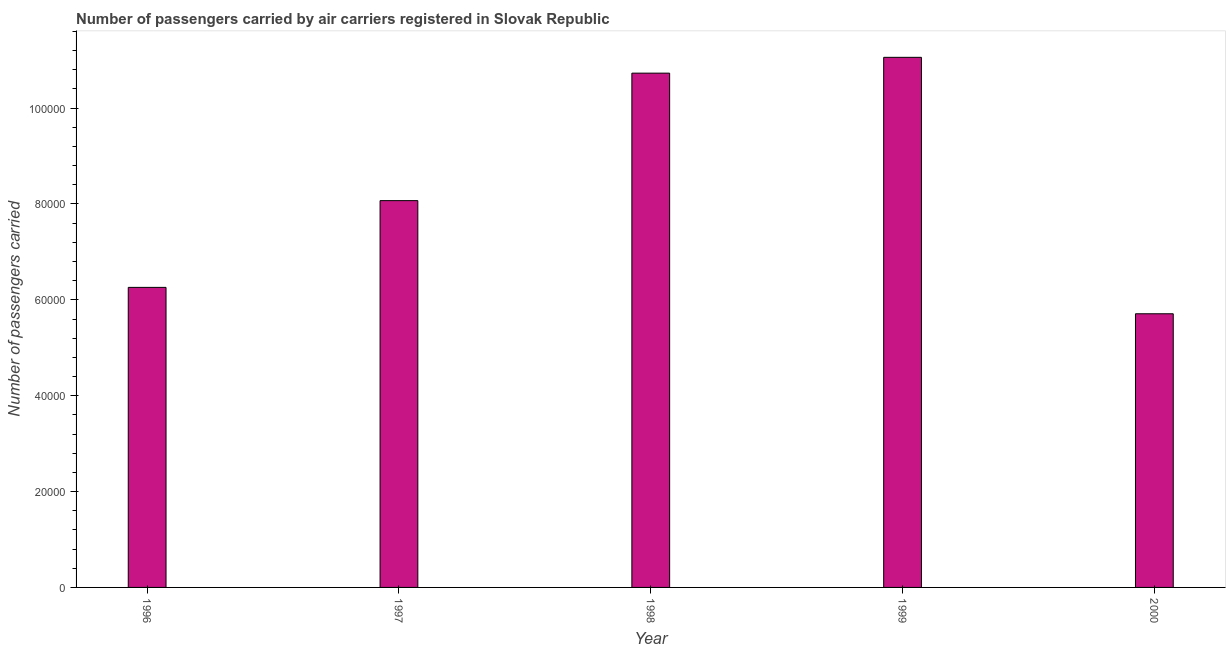Does the graph contain grids?
Your response must be concise. No. What is the title of the graph?
Offer a very short reply. Number of passengers carried by air carriers registered in Slovak Republic. What is the label or title of the Y-axis?
Provide a succinct answer. Number of passengers carried. What is the number of passengers carried in 1996?
Provide a succinct answer. 6.26e+04. Across all years, what is the maximum number of passengers carried?
Ensure brevity in your answer.  1.11e+05. Across all years, what is the minimum number of passengers carried?
Provide a short and direct response. 5.71e+04. In which year was the number of passengers carried minimum?
Ensure brevity in your answer.  2000. What is the sum of the number of passengers carried?
Provide a succinct answer. 4.18e+05. What is the difference between the number of passengers carried in 1997 and 1999?
Your answer should be very brief. -2.99e+04. What is the average number of passengers carried per year?
Provide a succinct answer. 8.37e+04. What is the median number of passengers carried?
Your response must be concise. 8.07e+04. In how many years, is the number of passengers carried greater than 68000 ?
Make the answer very short. 3. What is the ratio of the number of passengers carried in 1996 to that in 1999?
Offer a terse response. 0.57. Is the number of passengers carried in 1997 less than that in 1999?
Offer a terse response. Yes. Is the difference between the number of passengers carried in 1996 and 2000 greater than the difference between any two years?
Ensure brevity in your answer.  No. What is the difference between the highest and the second highest number of passengers carried?
Provide a succinct answer. 3300. What is the difference between the highest and the lowest number of passengers carried?
Give a very brief answer. 5.35e+04. What is the Number of passengers carried of 1996?
Your answer should be very brief. 6.26e+04. What is the Number of passengers carried of 1997?
Ensure brevity in your answer.  8.07e+04. What is the Number of passengers carried in 1998?
Keep it short and to the point. 1.07e+05. What is the Number of passengers carried of 1999?
Ensure brevity in your answer.  1.11e+05. What is the Number of passengers carried in 2000?
Ensure brevity in your answer.  5.71e+04. What is the difference between the Number of passengers carried in 1996 and 1997?
Ensure brevity in your answer.  -1.81e+04. What is the difference between the Number of passengers carried in 1996 and 1998?
Provide a succinct answer. -4.47e+04. What is the difference between the Number of passengers carried in 1996 and 1999?
Keep it short and to the point. -4.80e+04. What is the difference between the Number of passengers carried in 1996 and 2000?
Offer a very short reply. 5505. What is the difference between the Number of passengers carried in 1997 and 1998?
Offer a terse response. -2.66e+04. What is the difference between the Number of passengers carried in 1997 and 1999?
Offer a terse response. -2.99e+04. What is the difference between the Number of passengers carried in 1997 and 2000?
Offer a very short reply. 2.36e+04. What is the difference between the Number of passengers carried in 1998 and 1999?
Ensure brevity in your answer.  -3300. What is the difference between the Number of passengers carried in 1998 and 2000?
Make the answer very short. 5.02e+04. What is the difference between the Number of passengers carried in 1999 and 2000?
Offer a very short reply. 5.35e+04. What is the ratio of the Number of passengers carried in 1996 to that in 1997?
Offer a terse response. 0.78. What is the ratio of the Number of passengers carried in 1996 to that in 1998?
Keep it short and to the point. 0.58. What is the ratio of the Number of passengers carried in 1996 to that in 1999?
Offer a very short reply. 0.57. What is the ratio of the Number of passengers carried in 1996 to that in 2000?
Offer a terse response. 1.1. What is the ratio of the Number of passengers carried in 1997 to that in 1998?
Give a very brief answer. 0.75. What is the ratio of the Number of passengers carried in 1997 to that in 1999?
Your answer should be very brief. 0.73. What is the ratio of the Number of passengers carried in 1997 to that in 2000?
Give a very brief answer. 1.41. What is the ratio of the Number of passengers carried in 1998 to that in 2000?
Your answer should be very brief. 1.88. What is the ratio of the Number of passengers carried in 1999 to that in 2000?
Your response must be concise. 1.94. 